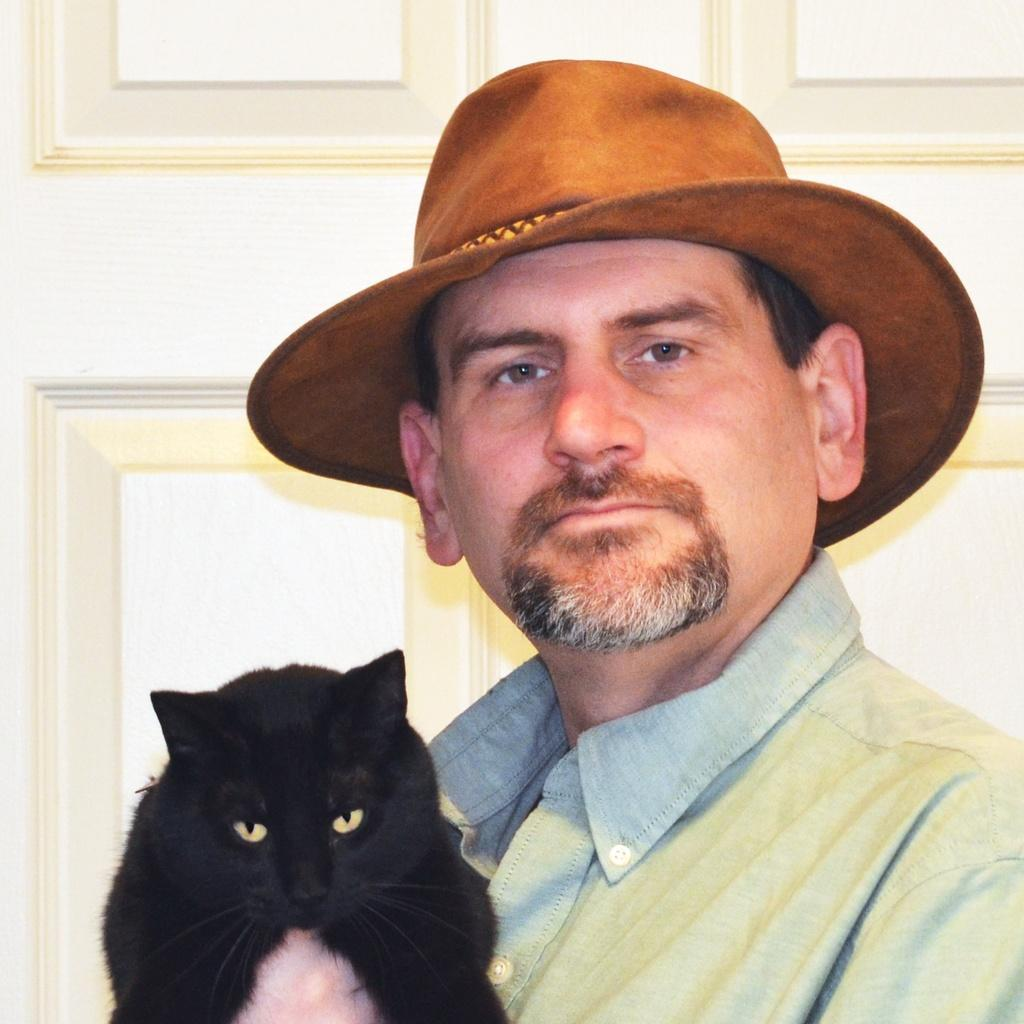What is the main subject of the image? The main subject of the image is a man. What is the man doing in the image? The man is holding a cat in his hand. Can you describe the man's attire in the image? The man is wearing a hat. How many ducks are visible in the image? There are no ducks present in the image. What type of comfort does the man provide for the cat in the image? The image does not show the man providing comfort for the cat; it only shows him holding the cat in his hand. 